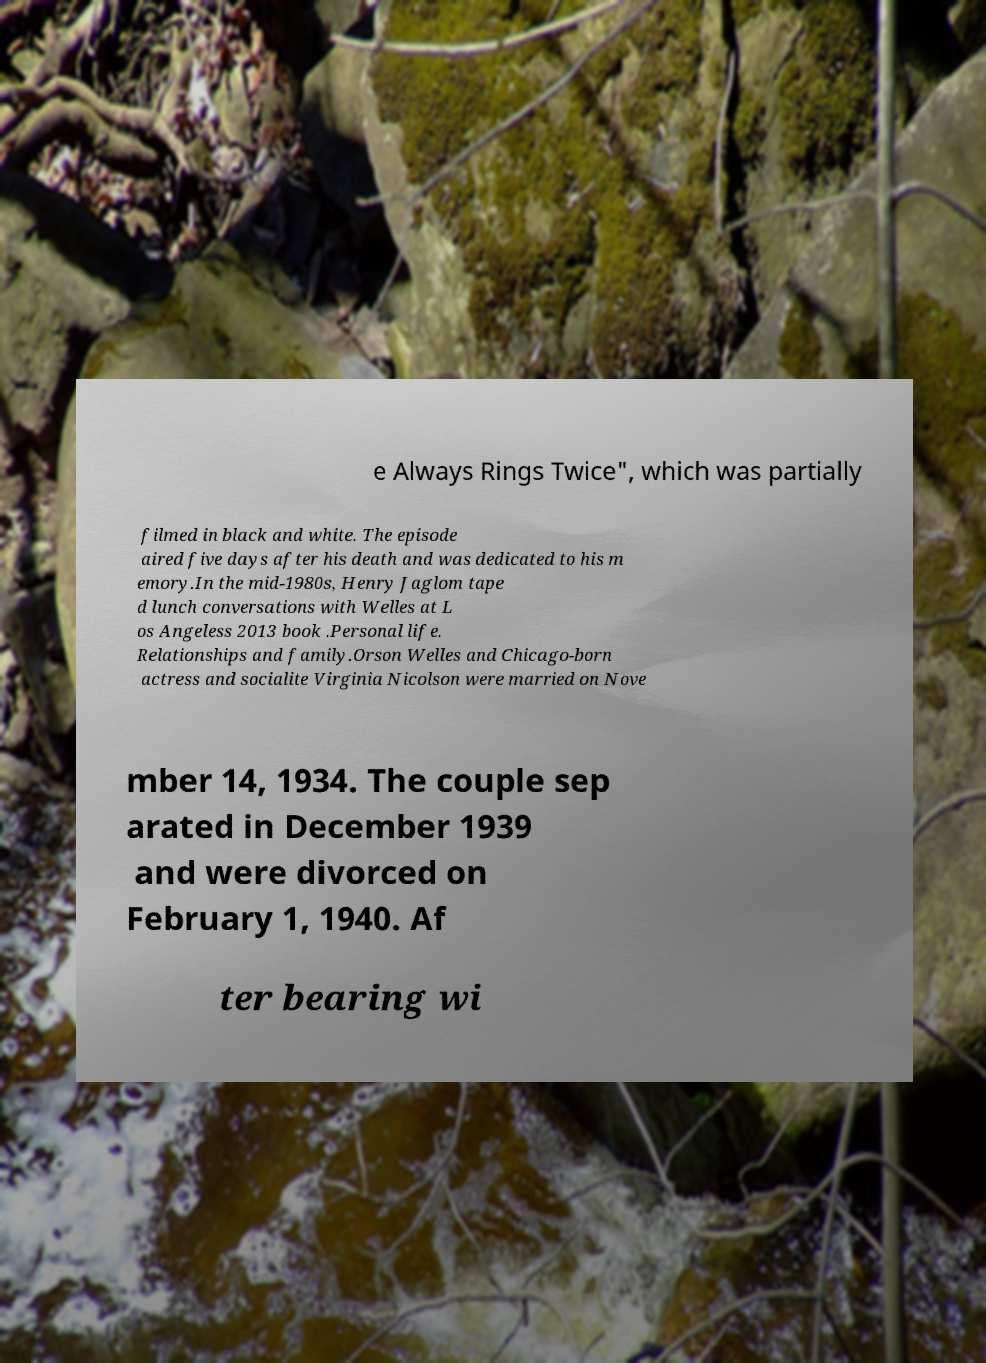Could you assist in decoding the text presented in this image and type it out clearly? e Always Rings Twice", which was partially filmed in black and white. The episode aired five days after his death and was dedicated to his m emory.In the mid-1980s, Henry Jaglom tape d lunch conversations with Welles at L os Angeless 2013 book .Personal life. Relationships and family.Orson Welles and Chicago-born actress and socialite Virginia Nicolson were married on Nove mber 14, 1934. The couple sep arated in December 1939 and were divorced on February 1, 1940. Af ter bearing wi 